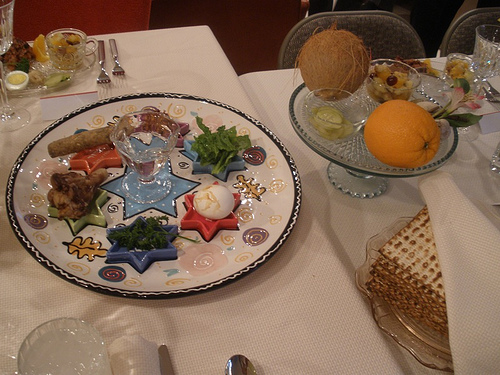Describe the type of meal or event this setup might be for. This image likely depicts a festive meal setup, possibly for a special occasion like a holiday dinner or a family gathering. The presence of a decorated platter with various foods and the festive presentation hints at a celebration. Can you name some of the specific food items visible in this image? The image shows a variety of food items including a hard-boiled egg, a bunch of fresh greens, chunks of meat, and different types of bread such as matzo. There's also an arrangement of fruits including an orange and a coconut. What type of celebration might include such a setup with these specific food items? This setup appears to be for a Passover Seder, a traditional Jewish ceremony that includes specific foods on the Seder plate. The hard-boiled egg, bitter herbs, and matzo are indicative of the ritual foods used during Passover. 